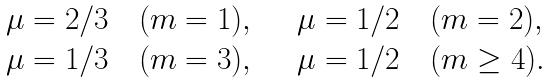<formula> <loc_0><loc_0><loc_500><loc_500>\begin{array} { l l } \mu = 2 / 3 \quad ( m = 1 ) , \quad & \mu = 1 / 2 \quad ( m = 2 ) , \\ \mu = 1 / 3 \quad ( m = 3 ) , \quad & \mu = 1 / 2 \quad ( m \geq 4 ) . \end{array}</formula> 